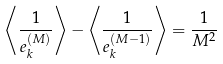<formula> <loc_0><loc_0><loc_500><loc_500>\left \langle \frac { 1 } { e _ { k } ^ { ( M ) } } \right \rangle - \left \langle \frac { 1 } { e _ { k } ^ { ( M - 1 ) } } \right \rangle = \frac { 1 } { M ^ { 2 } }</formula> 